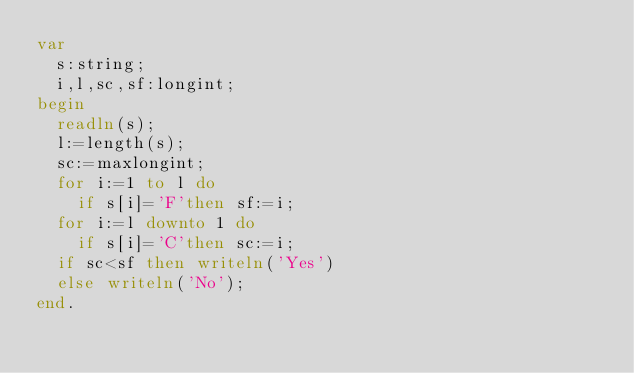<code> <loc_0><loc_0><loc_500><loc_500><_Pascal_>var
  s:string;
  i,l,sc,sf:longint; 
begin
  readln(s);
  l:=length(s);
  sc:=maxlongint;
  for i:=1 to l do 
    if s[i]='F'then sf:=i;
  for i:=l downto 1 do 
    if s[i]='C'then sc:=i;
  if sc<sf then writeln('Yes')
  else writeln('No');
end.</code> 